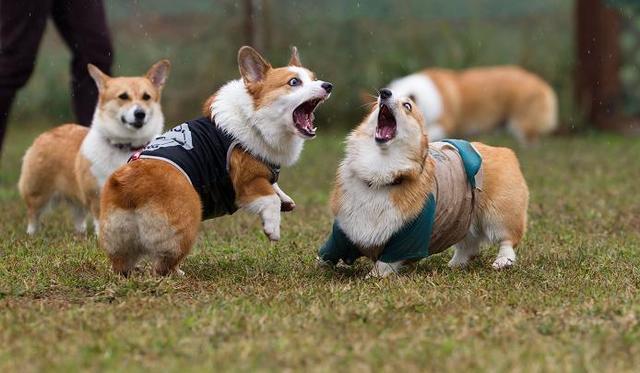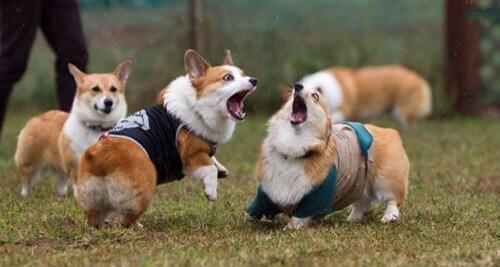The first image is the image on the left, the second image is the image on the right. Given the left and right images, does the statement "In at least one image there are three dog sitting next to each other in the grass." hold true? Answer yes or no. No. 